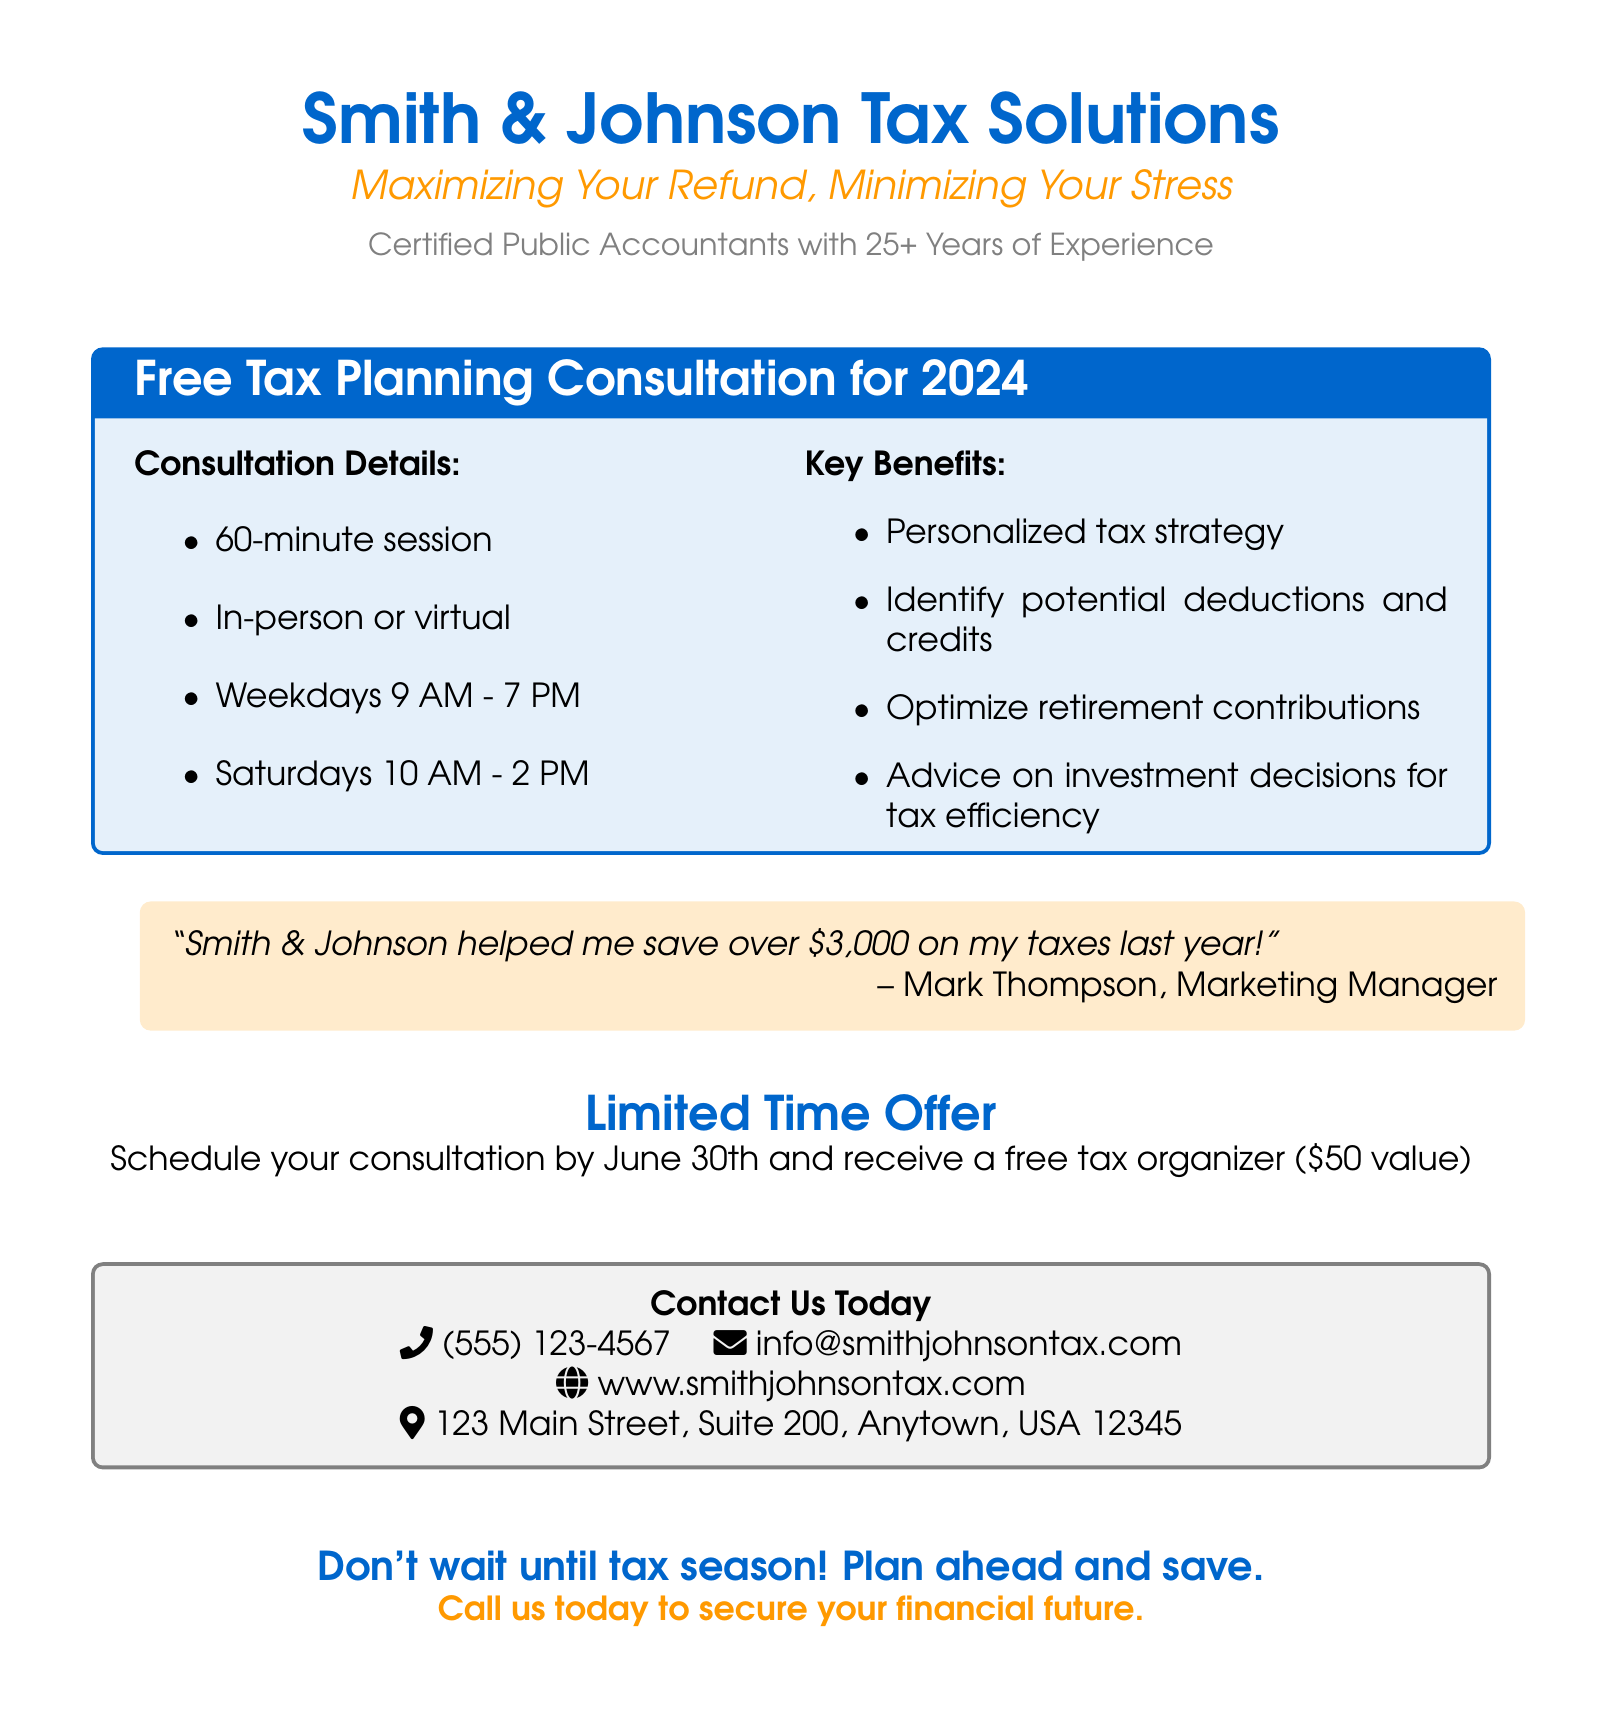What is the name of the accounting firm? The name of the accounting firm is specified in the document.
Answer: Smith & Johnson Tax Solutions What is the tagline of the firm? The tagline is prominently displayed under the firm's name in the document.
Answer: Maximizing Your Refund, Minimizing Your Stress How long is the consultation session? The duration of the consultation is mentioned clearly in the document.
Answer: 60-minute What are the available formats for the consultation? The document outlines the different formats that clients can choose for their consultation.
Answer: In-person or virtual What is the value of the free tax organizer? The document states the value of the tax organizer mentioned in the limited time offer.
Answer: $50 value Who provided the testimonial? The testimonial includes the name of the client, which is specified in the document.
Answer: Mark Thompson By what date should you schedule your consultation to receive the limited-time offer? The deadline for scheduling the consultation is clearly indicated in the document.
Answer: June 30th What is one of the key benefits of the consultation? The document lists several benefits, so this requires recalling any from the list.
Answer: Personalized tax strategy What time do they offer consultations on Saturdays? The document specifies the available hours for consultations on Saturdays.
Answer: 10 AM - 2 PM How can you contact the accounting firm? The contact information section provides various methods to reach the firm.
Answer: (555) 123-4567, info@smithjohnsontax.com 